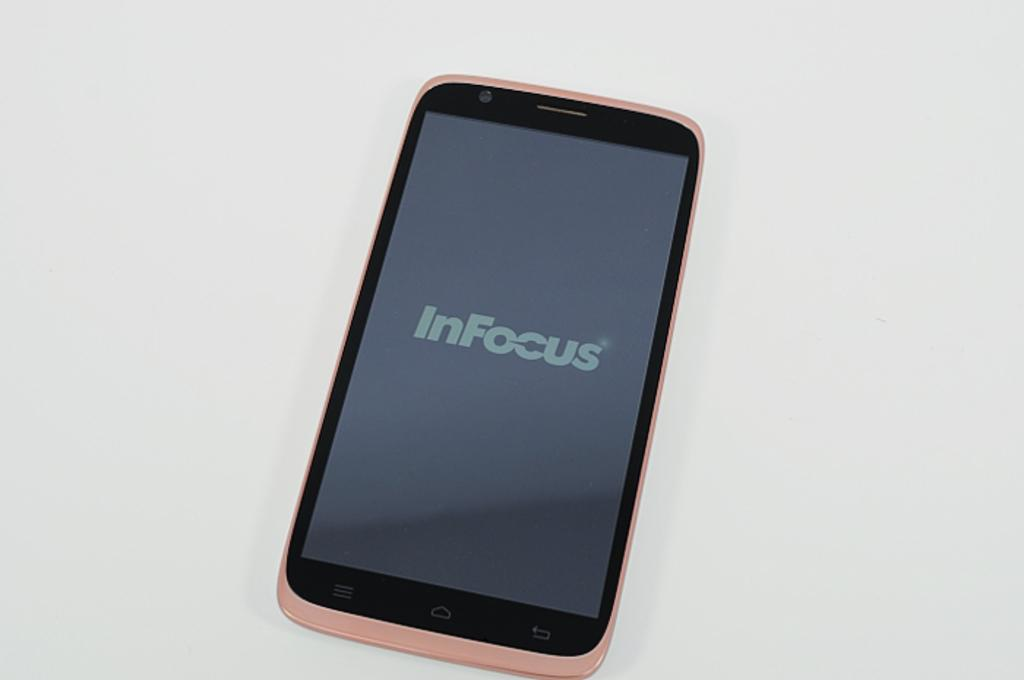Provide a one-sentence caption for the provided image. a pink cellphone with the words In Focus on the screen. 